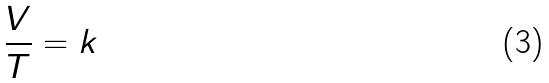<formula> <loc_0><loc_0><loc_500><loc_500>\frac { V } { T } = k</formula> 